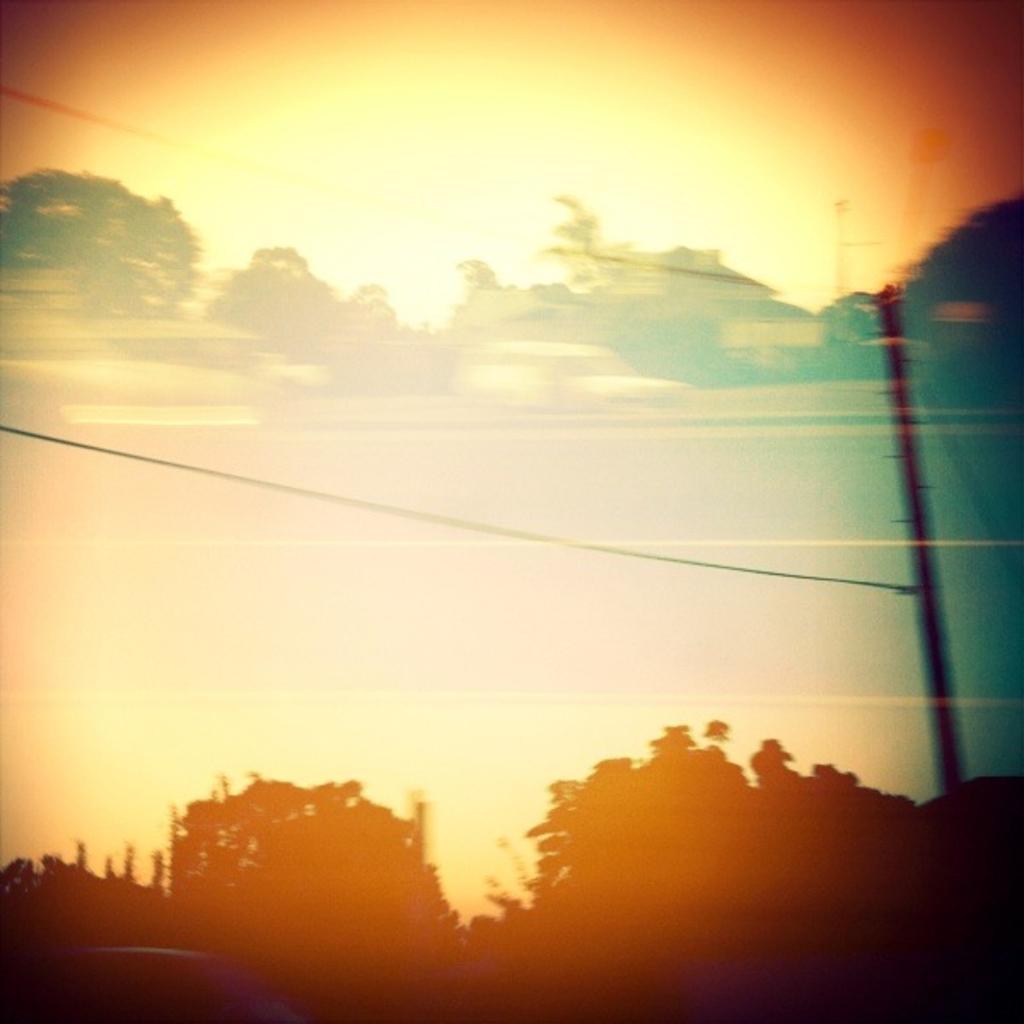Describe this image in one or two sentences. In this picture we can see trees at the bottom, on the right side there is a pole, we can see the sky in the background. 